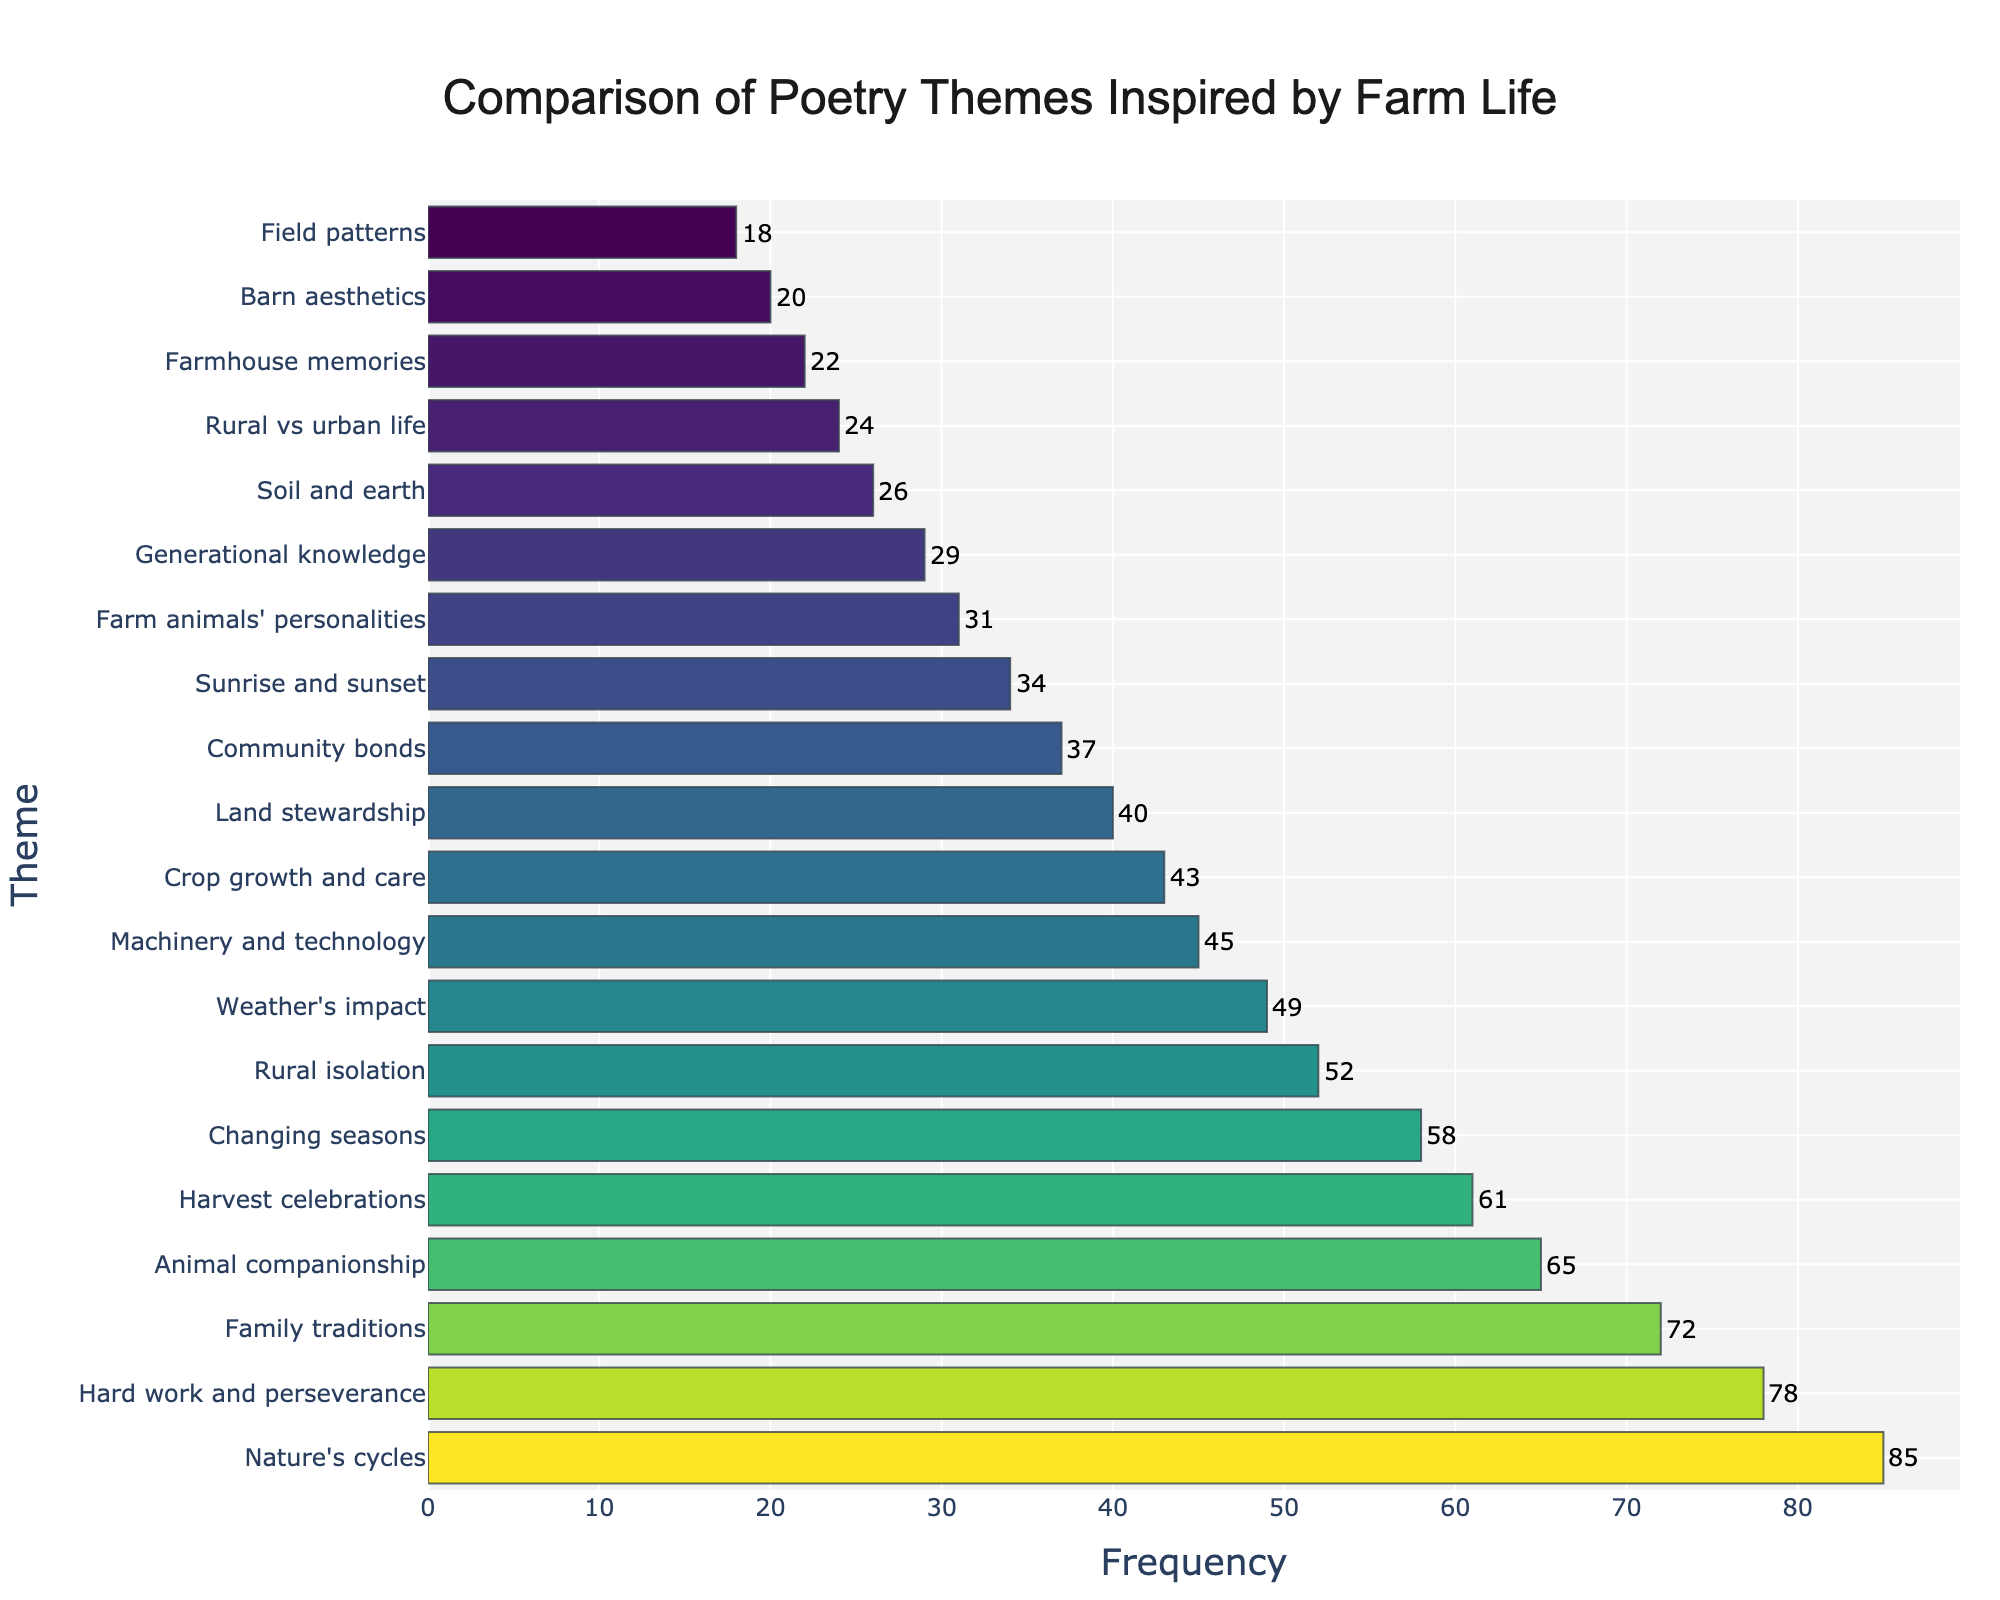What is the most common theme in the poetry inspired by farm life? The most common theme can be identified by the bar with the highest frequency in the figure. Looking at the figure, the theme "Nature's cycles" has the highest frequency at 85.
Answer: Nature's cycles How many more poems are there about "Weather's impact" compared to "Land stewardship"? To find the difference, locate the bars for "Weather's impact" (49) and "Land stewardship" (40) and subtract the smaller frequency from the larger one. 49 - 40 = 9.
Answer: 9 Which theme has a frequency closest to 50? Look at the bars around the value of 50 on the x-axis. The theme "Rural isolation" has a frequency of 52, which is closest to 50.
Answer: Rural isolation How many themes have a frequency greater than 60? Count the bars that exceed the frequency value of 60 on the x-axis. These are "Nature's cycles" (85), "Hard work and perseverance" (78), "Family traditions" (72), "Animal companionship" (65), and "Harvest celebrations" (61).
Answer: 5 What is the total frequency of the themes "Farmhouse memories" and "Barn aesthetics"? Sum the frequencies of "Farmhouse memories" (22) and "Barn aesthetics" (20). 22 + 20 = 42.
Answer: 42 Identify the theme with a frequency of 40. What color is its bar? Locate the theme with the frequency of 40. It is "Land stewardship". The color of its bar is determined by the colorscale "Viridis", which typically ranges from yellow to purple. Based on the ranking, it is a color near the middle of the scale.
Answer: Land stewardship, mid-range color on the Viridis scale (likely a shade of green) Which theme has the second highest frequency? The bar just below the highest bar represents the second highest frequency. This theme is "Hard work and perseverance" with a frequency of 78.
Answer: Hard work and perseverance What is the average frequency of the themes "Community bonds", "Sunrise and sunset", and "Farm animals' personalities"? Calculate the average by summing the frequencies of these themes and dividing by the number of themes. (37 + 34 + 31) / 3 = 34.
Answer: 34 Are there more themes related to "Machinery and technology" or "Soil and earth"? Compare the frequencies of "Machinery and technology" (45) and "Soil and earth" (26). "Machinery and technology" has more themes.
Answer: Machinery and technology What is the median frequency of all themes? To find the median, order the frequencies and find the middle value. The frequencies ordered are: 18, 20, 22, 24, 26, 29, 31, 34, 37, 40, 43, 45, 49, 52, 58, 61, 65, 72, 78, 85. There are 20 themes, so the median will be the average of the 10th and 11th values. (40 + 43) / 2 = 41.5.
Answer: 41.5 